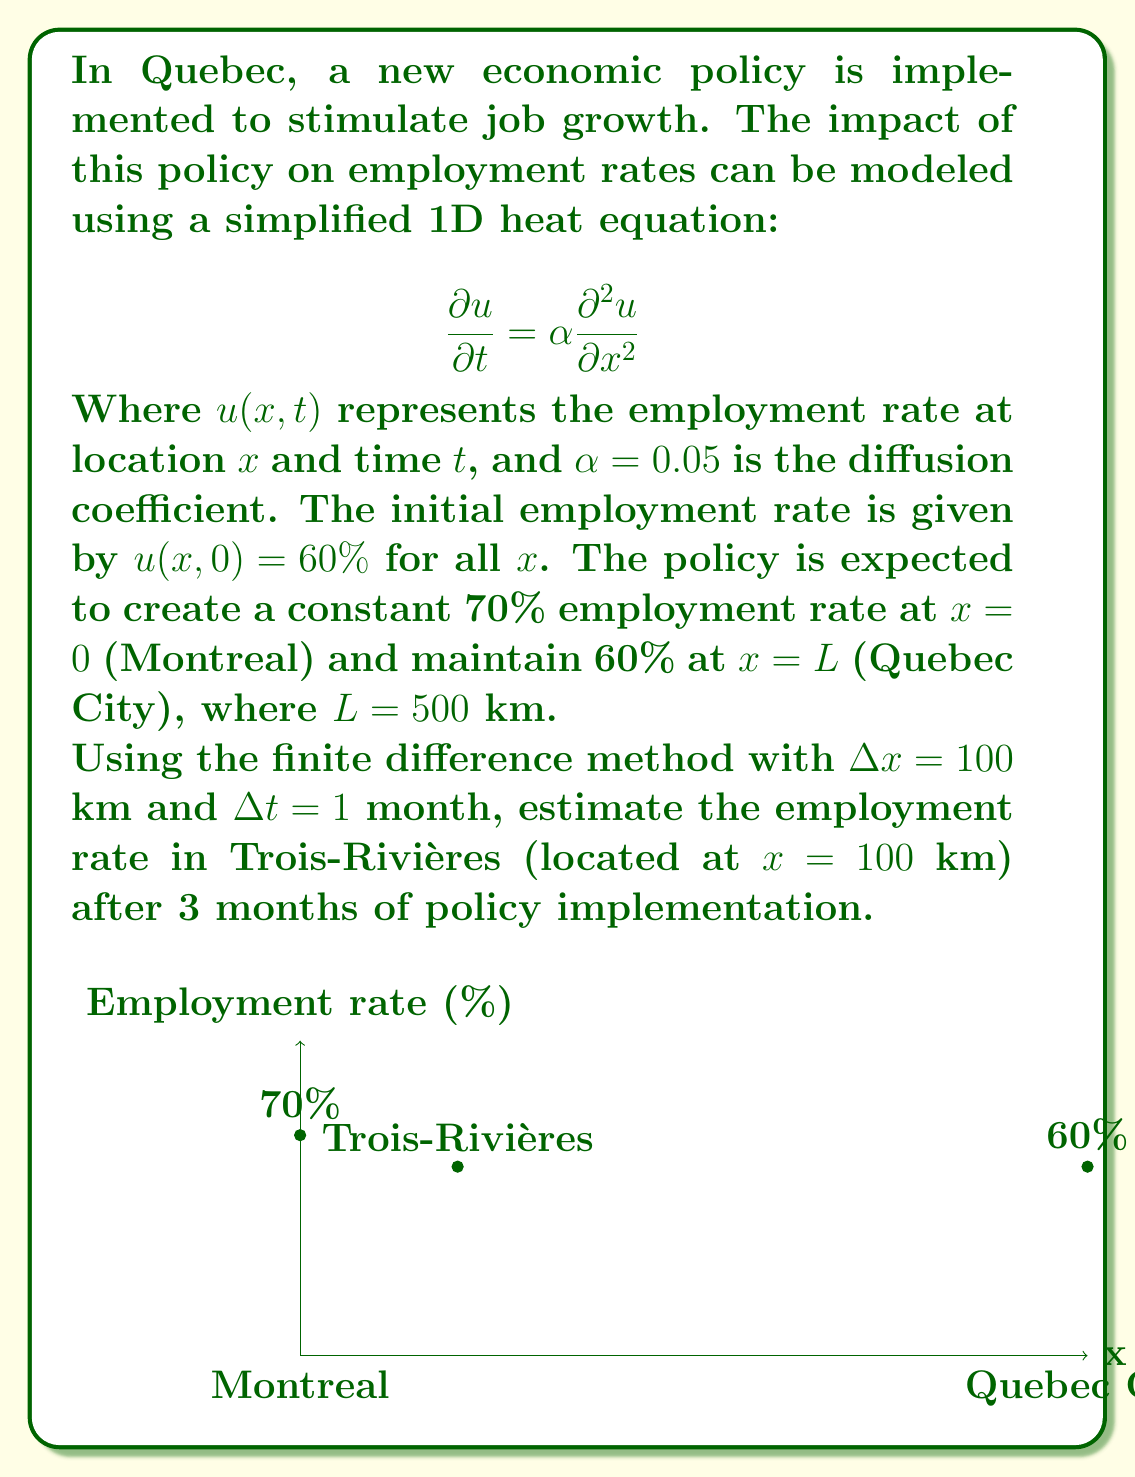Solve this math problem. To solve this problem, we'll use the explicit finite difference method for the heat equation:

1) The finite difference approximation for the heat equation is:

   $$\frac{u_i^{n+1} - u_i^n}{\Delta t} = \alpha \frac{u_{i+1}^n - 2u_i^n + u_{i-1}^n}{(\Delta x)^2}$$

2) Rearranging to solve for $u_i^{n+1}$:

   $$u_i^{n+1} = u_i^n + \frac{\alpha \Delta t}{(\Delta x)^2}(u_{i+1}^n - 2u_i^n + u_{i-1}^n)$$

3) Calculate the stability condition $r = \frac{\alpha \Delta t}{(\Delta x)^2}$:

   $$r = \frac{0.05 \cdot 1}{100^2} = 0.000005 < 0.5$$

   The scheme is stable.

4) Set up the initial and boundary conditions:
   - $u_i^0 = 60\%$ for all $i$
   - $u_0^n = 70\%$ and $u_5^n = 60\%$ for all $n$

5) Calculate for 3 time steps (3 months):

   For $n = 0$ to $2$:
   $$u_1^{n+1} = u_1^n + 0.000005(u_2^n - 2u_1^n + 70\%)$$

6) Compute the values:
   - After 1 month: $u_1^1 = 60\% + 0.000005(60\% - 120\% + 70\%) = 60.00025\%$
   - After 2 months: $u_1^2 = 60.00025\% + 0.000005(60\% - 120.0005\% + 70\%) = 60.00050\%$
   - After 3 months: $u_1^3 = 60.00050\% + 0.000005(60\% - 120.001\% + 70\%) = 60.00075\%$

Therefore, the estimated employment rate in Trois-Rivières after 3 months is approximately 60.00075%.
Answer: 60.00075% 